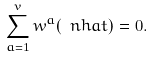Convert formula to latex. <formula><loc_0><loc_0><loc_500><loc_500>\sum _ { a = 1 } ^ { v } w ^ { a } ( \ n h a t ) = 0 .</formula> 